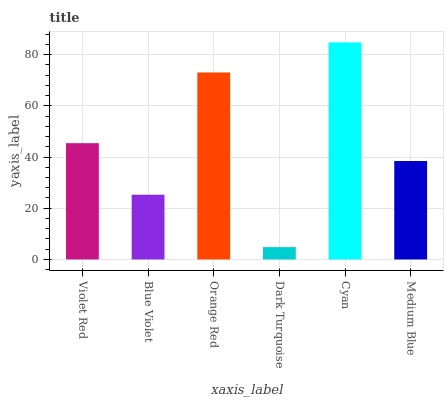Is Dark Turquoise the minimum?
Answer yes or no. Yes. Is Cyan the maximum?
Answer yes or no. Yes. Is Blue Violet the minimum?
Answer yes or no. No. Is Blue Violet the maximum?
Answer yes or no. No. Is Violet Red greater than Blue Violet?
Answer yes or no. Yes. Is Blue Violet less than Violet Red?
Answer yes or no. Yes. Is Blue Violet greater than Violet Red?
Answer yes or no. No. Is Violet Red less than Blue Violet?
Answer yes or no. No. Is Violet Red the high median?
Answer yes or no. Yes. Is Medium Blue the low median?
Answer yes or no. Yes. Is Cyan the high median?
Answer yes or no. No. Is Cyan the low median?
Answer yes or no. No. 